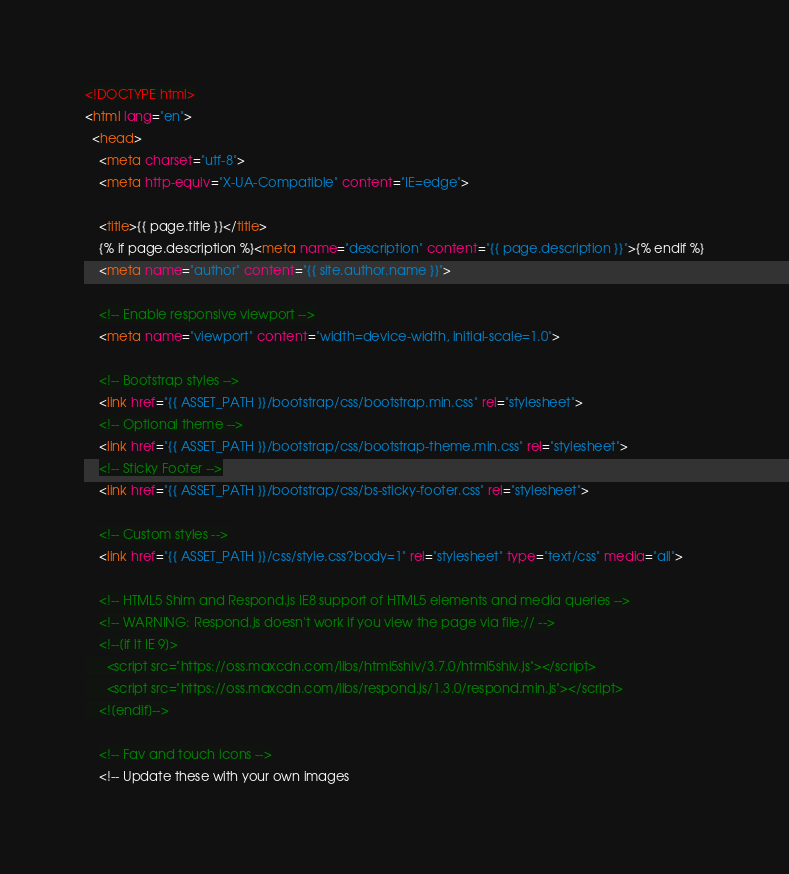Convert code to text. <code><loc_0><loc_0><loc_500><loc_500><_HTML_><!DOCTYPE html>
<html lang="en">
  <head>
    <meta charset="utf-8">
    <meta http-equiv="X-UA-Compatible" content="IE=edge">

    <title>{{ page.title }}</title>
    {% if page.description %}<meta name="description" content="{{ page.description }}">{% endif %}
    <meta name="author" content="{{ site.author.name }}">

    <!-- Enable responsive viewport -->
    <meta name="viewport" content="width=device-width, initial-scale=1.0">

    <!-- Bootstrap styles -->
    <link href="{{ ASSET_PATH }}/bootstrap/css/bootstrap.min.css" rel="stylesheet">
    <!-- Optional theme -->
    <link href="{{ ASSET_PATH }}/bootstrap/css/bootstrap-theme.min.css" rel="stylesheet">
    <!-- Sticky Footer -->
    <link href="{{ ASSET_PATH }}/bootstrap/css/bs-sticky-footer.css" rel="stylesheet">

    <!-- Custom styles -->
    <link href="{{ ASSET_PATH }}/css/style.css?body=1" rel="stylesheet" type="text/css" media="all">

    <!-- HTML5 Shim and Respond.js IE8 support of HTML5 elements and media queries -->
    <!-- WARNING: Respond.js doesn't work if you view the page via file:// -->
    <!--[if lt IE 9]>
      <script src="https://oss.maxcdn.com/libs/html5shiv/3.7.0/html5shiv.js"></script>
      <script src="https://oss.maxcdn.com/libs/respond.js/1.3.0/respond.min.js"></script>
    <![endif]-->

    <!-- Fav and touch icons -->
    <!-- Update these with your own images</code> 